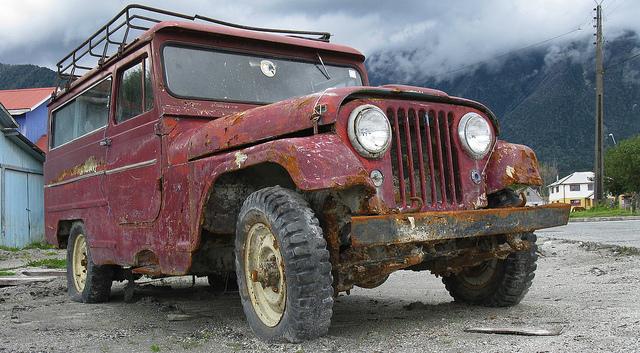Are the tires flat?
Write a very short answer. Yes. Are the lights on?
Be succinct. No. Can one still drive this car?
Be succinct. No. 